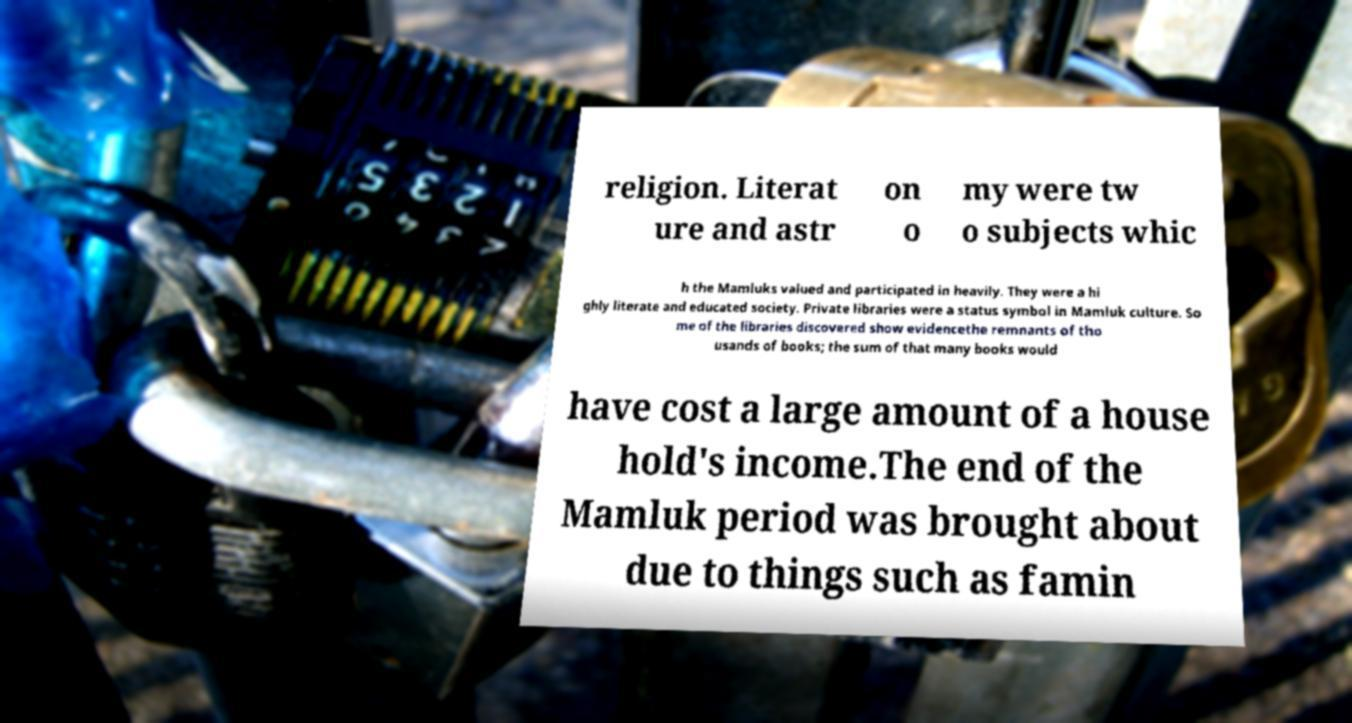I need the written content from this picture converted into text. Can you do that? religion. Literat ure and astr on o my were tw o subjects whic h the Mamluks valued and participated in heavily. They were a hi ghly literate and educated society. Private libraries were a status symbol in Mamluk culture. So me of the libraries discovered show evidencethe remnants of tho usands of books; the sum of that many books would have cost a large amount of a house hold's income.The end of the Mamluk period was brought about due to things such as famin 